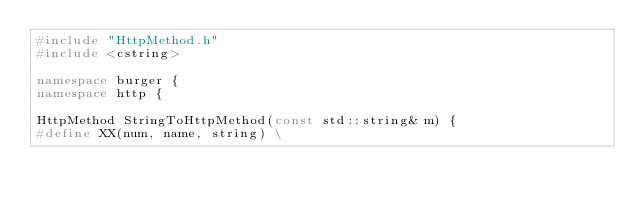<code> <loc_0><loc_0><loc_500><loc_500><_C++_>#include "HttpMethod.h"
#include <cstring>

namespace burger {
namespace http {

HttpMethod StringToHttpMethod(const std::string& m) {
#define XX(num, name, string) \</code> 